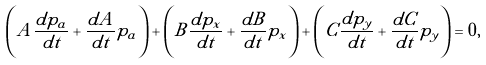<formula> <loc_0><loc_0><loc_500><loc_500>\left ( A \frac { d p _ { a } } { d t } + \frac { d A } { d t } p _ { a } \right ) + \left ( B \frac { d p _ { x } } { d t } + \frac { d B } { d t } p _ { x } \right ) + \left ( C \frac { d p _ { y } } { d t } + \frac { d C } { d t } p _ { y } \right ) = 0 ,</formula> 